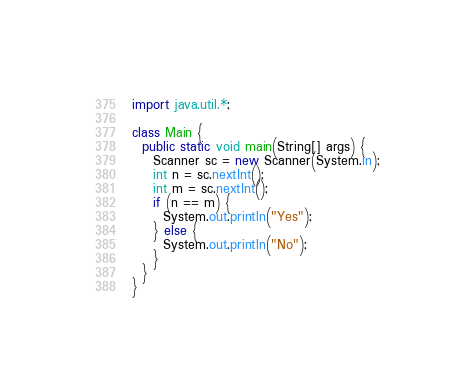<code> <loc_0><loc_0><loc_500><loc_500><_Java_>import java.util.*;

class Main {
  public static void main(String[] args) {
    Scanner sc = new Scanner(System.in);
    int n = sc.nextInt();
    int m = sc.nextInt();
    if (n == m) {
      System.out.println("Yes");
    } else {
      System.out.println("No");
    }
  }
}</code> 